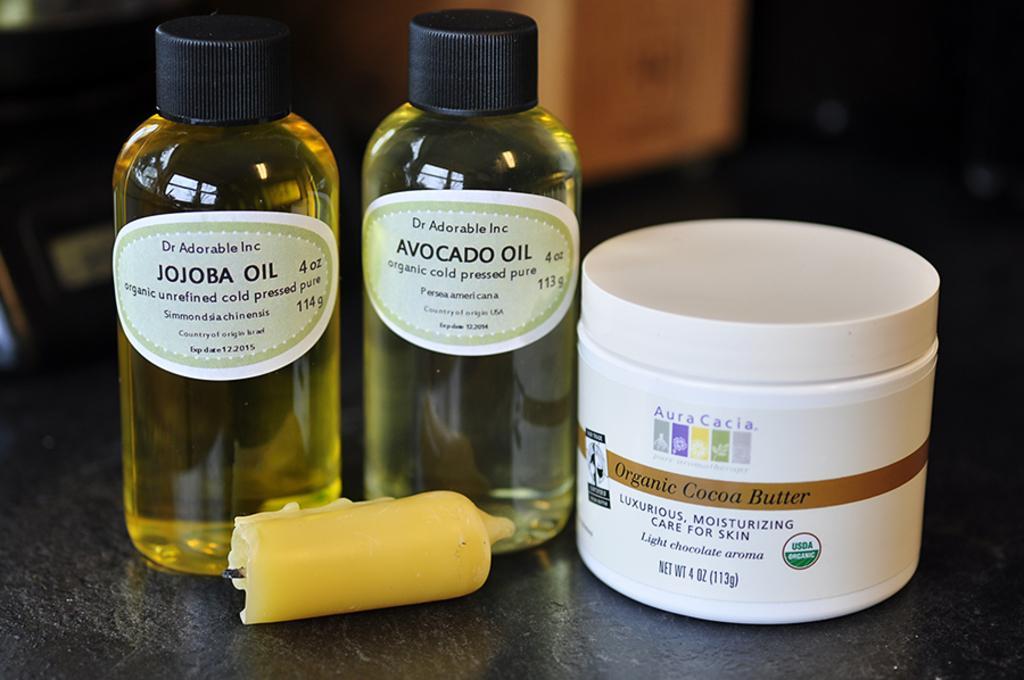Please provide a concise description of this image. In this image we can see the bottles, box and a candle. We can see labels on the bottles and the box. On the label we can see the text. The background of the image is blurred. 